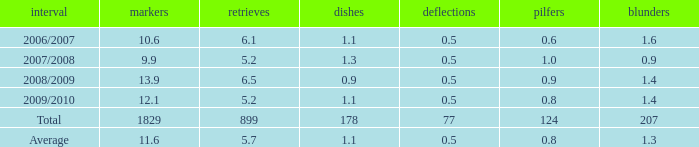What is the maximum rebounds when there are 0.9 steals and fewer than 1.4 turnovers? None. 